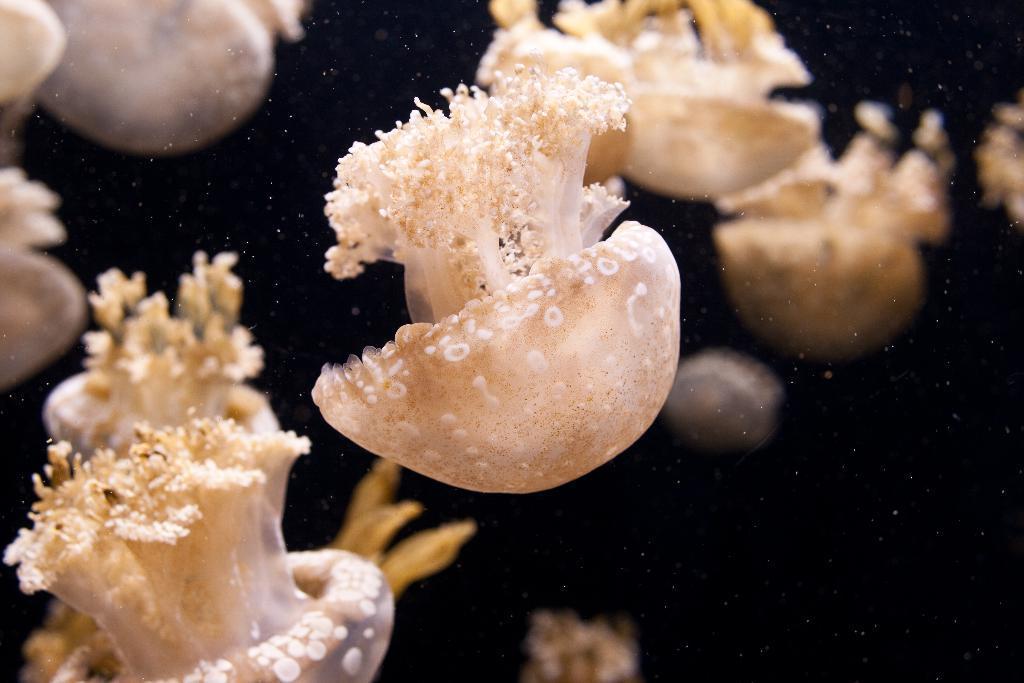Describe this image in one or two sentences. In this image I can see some jellyfish which are in white and cream color. And there is a black background. 